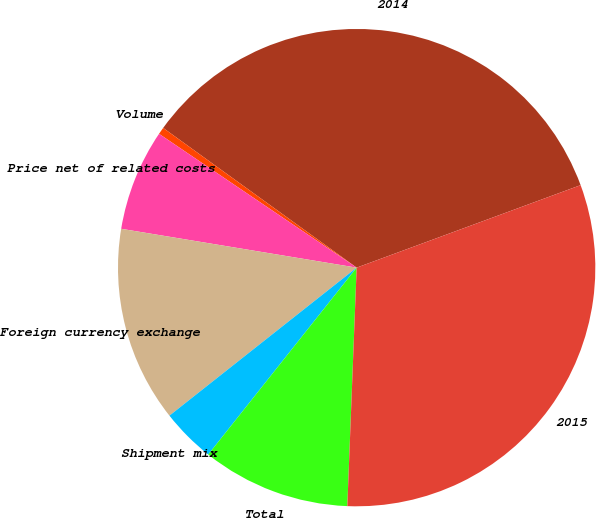Convert chart. <chart><loc_0><loc_0><loc_500><loc_500><pie_chart><fcel>2014<fcel>Volume<fcel>Price net of related costs<fcel>Foreign currency exchange<fcel>Shipment mix<fcel>Total<fcel>2015<nl><fcel>34.43%<fcel>0.48%<fcel>6.87%<fcel>13.25%<fcel>3.67%<fcel>10.06%<fcel>31.24%<nl></chart> 